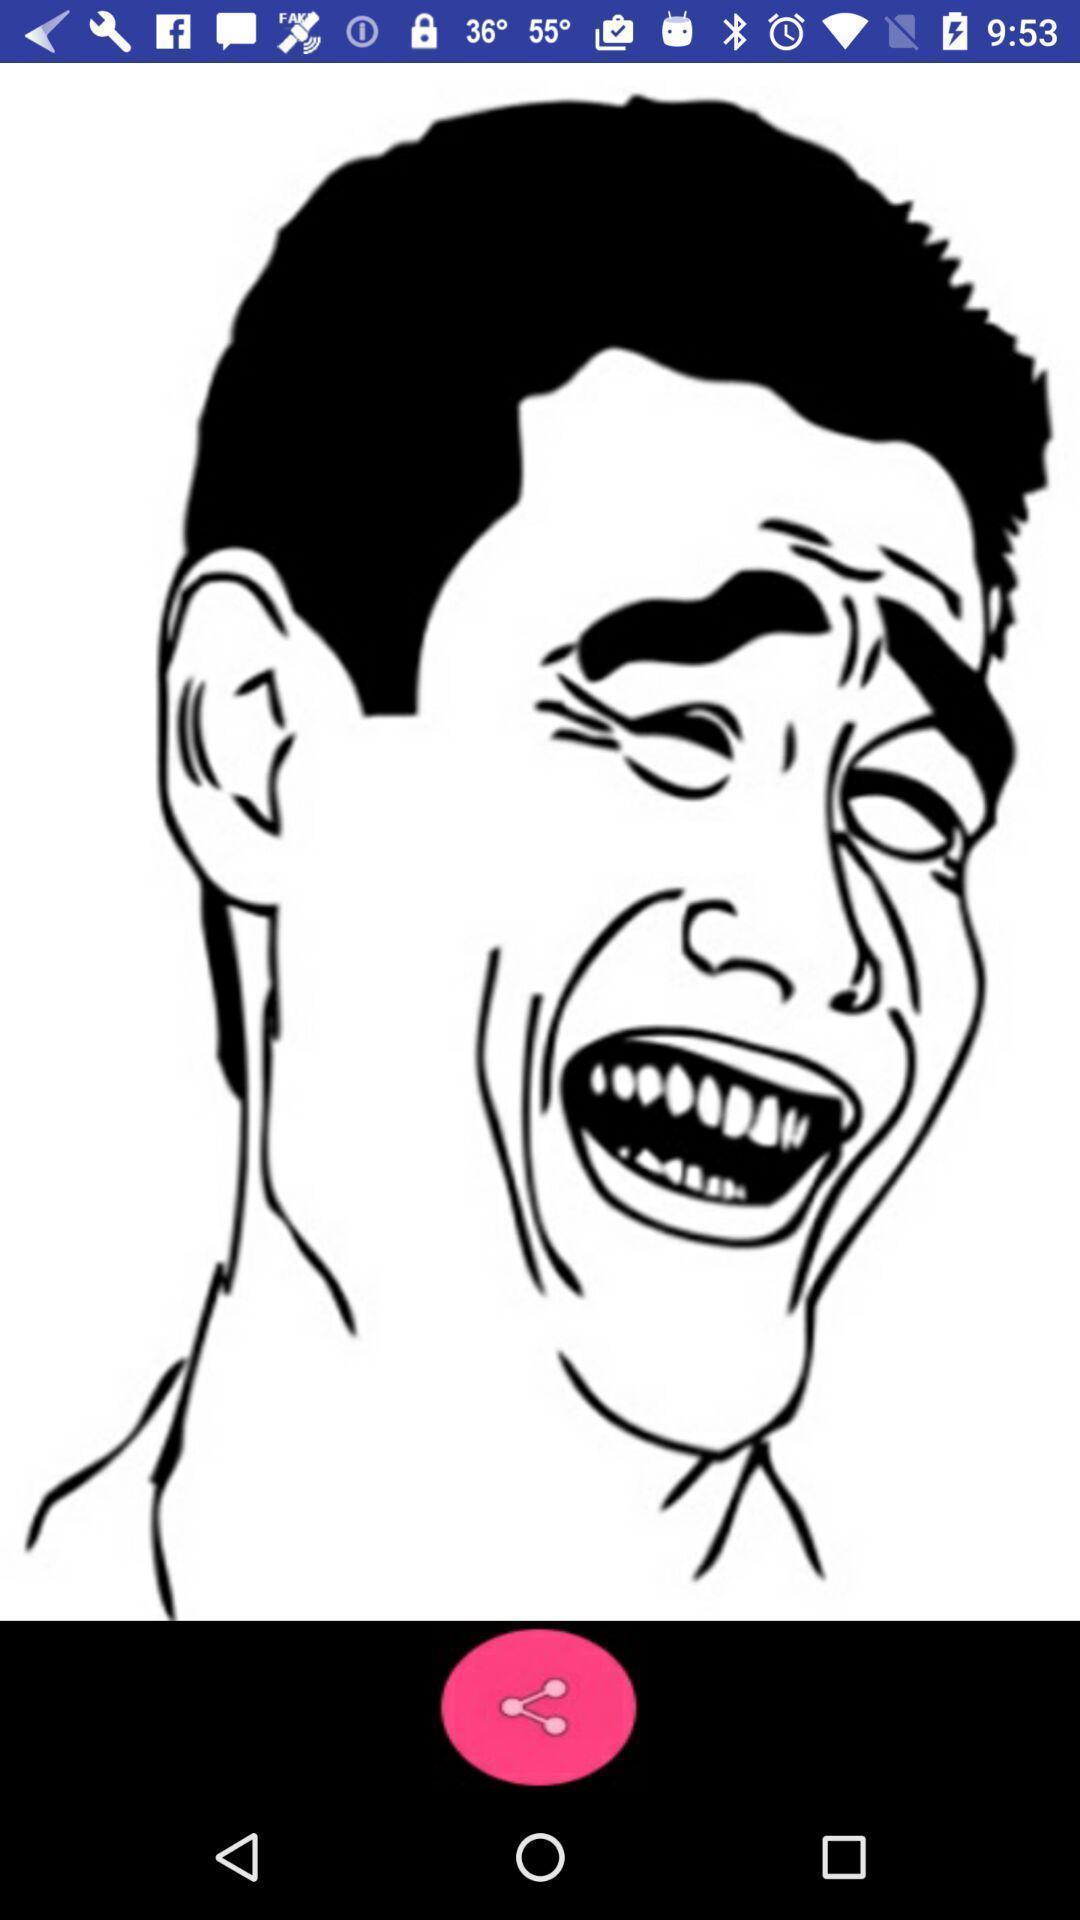What is the overall content of this screenshot? Screen displaying an image with share option. 